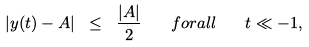<formula> <loc_0><loc_0><loc_500><loc_500>\left | y ( t ) - A \right | \ \leq \ \frac { | A | } { 2 } \quad f o r a l l \quad t \ll - 1 ,</formula> 